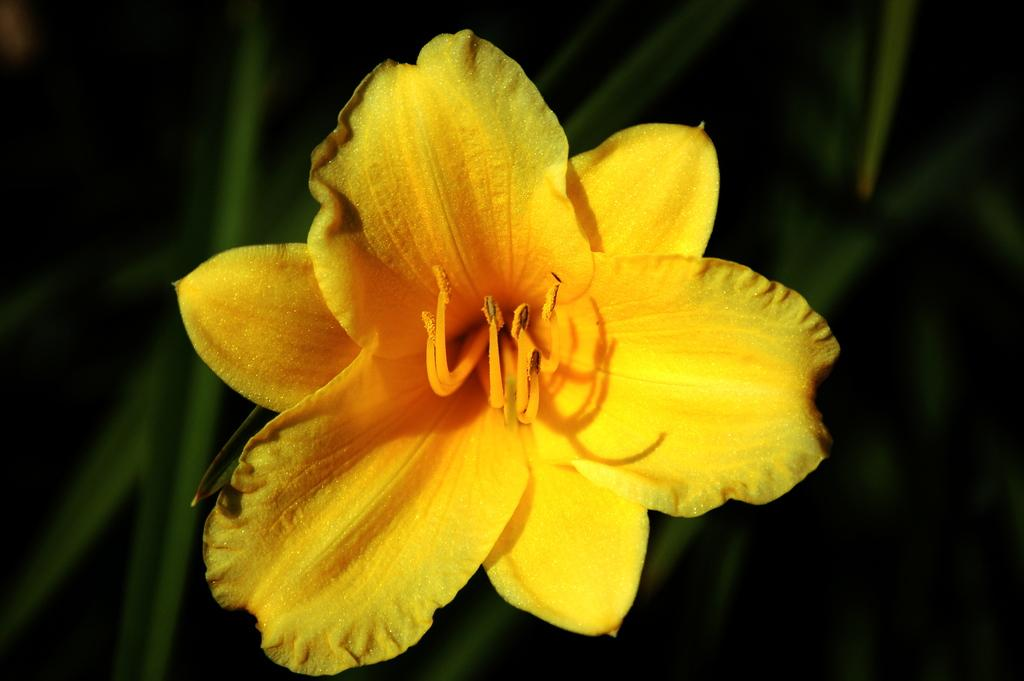What type of flower can be seen in the picture? There is a yellow color flower in the picture. What color is the background of the picture? The background of the picture is green. How many weeks does the flower take to perform magic in the picture? There is no mention of magic or a specific time frame for the flower to perform any action in the image. 